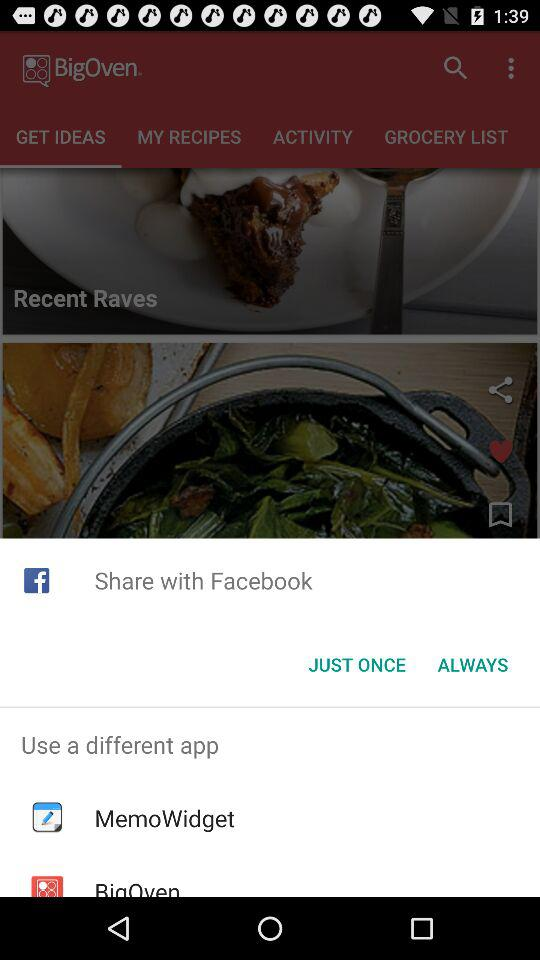How many items are on the grocery list?
When the provided information is insufficient, respond with <no answer>. <no answer> 